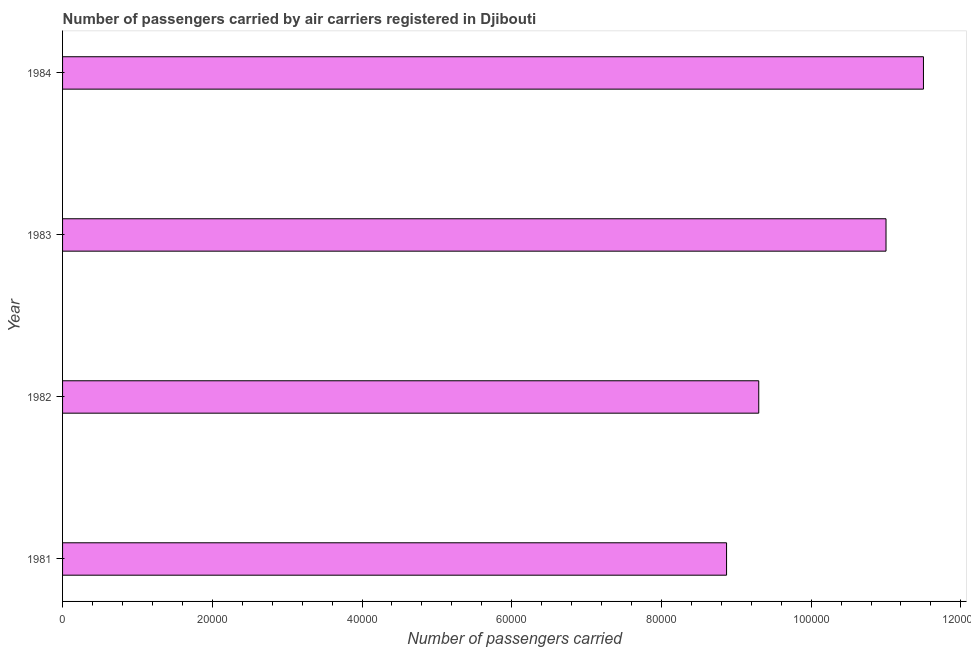Does the graph contain any zero values?
Make the answer very short. No. What is the title of the graph?
Your response must be concise. Number of passengers carried by air carriers registered in Djibouti. What is the label or title of the X-axis?
Ensure brevity in your answer.  Number of passengers carried. Across all years, what is the maximum number of passengers carried?
Provide a short and direct response. 1.15e+05. Across all years, what is the minimum number of passengers carried?
Your answer should be very brief. 8.87e+04. In which year was the number of passengers carried minimum?
Make the answer very short. 1981. What is the sum of the number of passengers carried?
Offer a very short reply. 4.07e+05. What is the difference between the number of passengers carried in 1981 and 1983?
Provide a short and direct response. -2.13e+04. What is the average number of passengers carried per year?
Make the answer very short. 1.02e+05. What is the median number of passengers carried?
Make the answer very short. 1.02e+05. In how many years, is the number of passengers carried greater than 16000 ?
Provide a short and direct response. 4. Do a majority of the years between 1983 and 1981 (inclusive) have number of passengers carried greater than 64000 ?
Give a very brief answer. Yes. What is the ratio of the number of passengers carried in 1982 to that in 1984?
Your answer should be very brief. 0.81. Is the number of passengers carried in 1982 less than that in 1984?
Your answer should be compact. Yes. Is the difference between the number of passengers carried in 1983 and 1984 greater than the difference between any two years?
Keep it short and to the point. No. What is the difference between the highest and the second highest number of passengers carried?
Your answer should be very brief. 5000. Is the sum of the number of passengers carried in 1981 and 1982 greater than the maximum number of passengers carried across all years?
Make the answer very short. Yes. What is the difference between the highest and the lowest number of passengers carried?
Provide a short and direct response. 2.63e+04. How many bars are there?
Offer a very short reply. 4. How many years are there in the graph?
Keep it short and to the point. 4. Are the values on the major ticks of X-axis written in scientific E-notation?
Give a very brief answer. No. What is the Number of passengers carried in 1981?
Your response must be concise. 8.87e+04. What is the Number of passengers carried of 1982?
Make the answer very short. 9.30e+04. What is the Number of passengers carried of 1983?
Give a very brief answer. 1.10e+05. What is the Number of passengers carried in 1984?
Offer a terse response. 1.15e+05. What is the difference between the Number of passengers carried in 1981 and 1982?
Make the answer very short. -4300. What is the difference between the Number of passengers carried in 1981 and 1983?
Your response must be concise. -2.13e+04. What is the difference between the Number of passengers carried in 1981 and 1984?
Provide a succinct answer. -2.63e+04. What is the difference between the Number of passengers carried in 1982 and 1983?
Provide a short and direct response. -1.70e+04. What is the difference between the Number of passengers carried in 1982 and 1984?
Ensure brevity in your answer.  -2.20e+04. What is the difference between the Number of passengers carried in 1983 and 1984?
Provide a short and direct response. -5000. What is the ratio of the Number of passengers carried in 1981 to that in 1982?
Your response must be concise. 0.95. What is the ratio of the Number of passengers carried in 1981 to that in 1983?
Ensure brevity in your answer.  0.81. What is the ratio of the Number of passengers carried in 1981 to that in 1984?
Your response must be concise. 0.77. What is the ratio of the Number of passengers carried in 1982 to that in 1983?
Give a very brief answer. 0.84. What is the ratio of the Number of passengers carried in 1982 to that in 1984?
Make the answer very short. 0.81. 